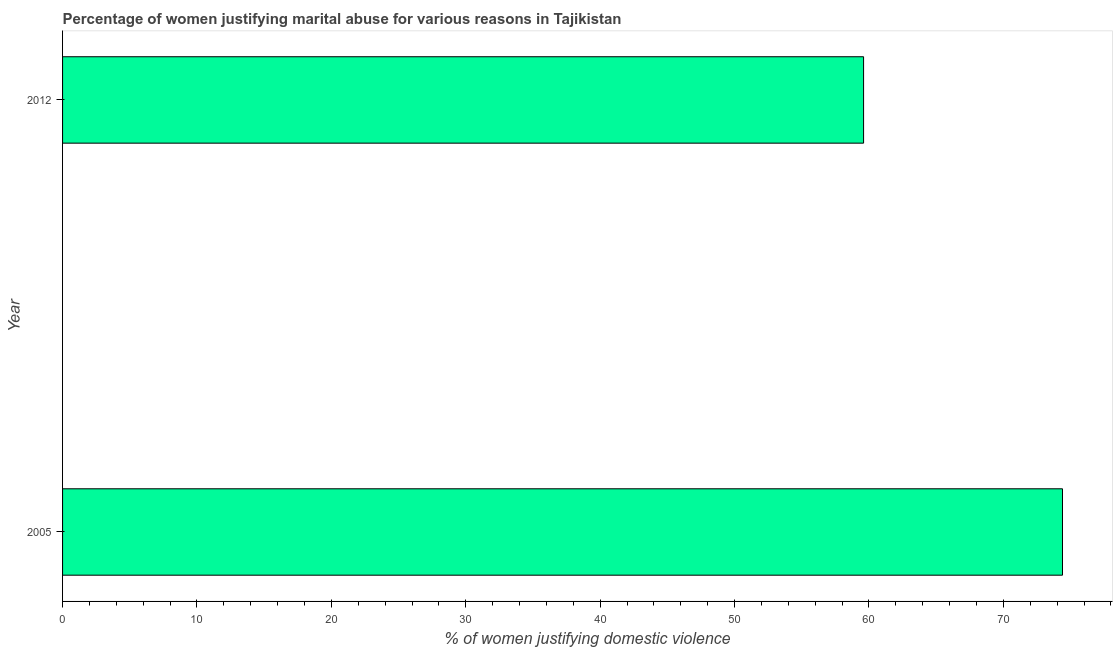Does the graph contain grids?
Provide a short and direct response. No. What is the title of the graph?
Offer a very short reply. Percentage of women justifying marital abuse for various reasons in Tajikistan. What is the label or title of the X-axis?
Provide a short and direct response. % of women justifying domestic violence. What is the label or title of the Y-axis?
Your response must be concise. Year. What is the percentage of women justifying marital abuse in 2012?
Offer a very short reply. 59.6. Across all years, what is the maximum percentage of women justifying marital abuse?
Your answer should be compact. 74.4. Across all years, what is the minimum percentage of women justifying marital abuse?
Give a very brief answer. 59.6. In which year was the percentage of women justifying marital abuse maximum?
Provide a short and direct response. 2005. What is the sum of the percentage of women justifying marital abuse?
Offer a terse response. 134. What is the average percentage of women justifying marital abuse per year?
Ensure brevity in your answer.  67. What is the ratio of the percentage of women justifying marital abuse in 2005 to that in 2012?
Your answer should be compact. 1.25. How many bars are there?
Give a very brief answer. 2. Are all the bars in the graph horizontal?
Make the answer very short. Yes. How many years are there in the graph?
Your answer should be compact. 2. What is the difference between two consecutive major ticks on the X-axis?
Provide a succinct answer. 10. Are the values on the major ticks of X-axis written in scientific E-notation?
Make the answer very short. No. What is the % of women justifying domestic violence of 2005?
Your response must be concise. 74.4. What is the % of women justifying domestic violence of 2012?
Ensure brevity in your answer.  59.6. What is the ratio of the % of women justifying domestic violence in 2005 to that in 2012?
Provide a short and direct response. 1.25. 